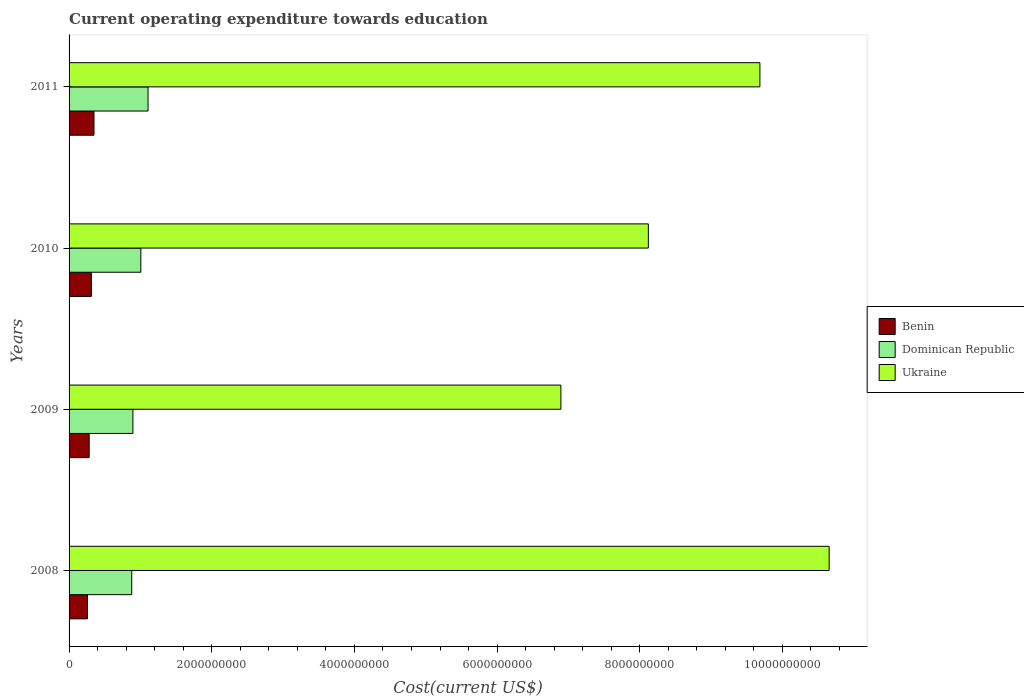How many different coloured bars are there?
Offer a terse response. 3. How many groups of bars are there?
Your response must be concise. 4. How many bars are there on the 3rd tick from the bottom?
Provide a succinct answer. 3. In how many cases, is the number of bars for a given year not equal to the number of legend labels?
Your answer should be very brief. 0. What is the expenditure towards education in Benin in 2009?
Ensure brevity in your answer.  2.82e+08. Across all years, what is the maximum expenditure towards education in Ukraine?
Provide a succinct answer. 1.07e+1. Across all years, what is the minimum expenditure towards education in Dominican Republic?
Your answer should be compact. 8.78e+08. In which year was the expenditure towards education in Dominican Republic maximum?
Provide a short and direct response. 2011. In which year was the expenditure towards education in Dominican Republic minimum?
Your response must be concise. 2008. What is the total expenditure towards education in Ukraine in the graph?
Keep it short and to the point. 3.54e+1. What is the difference between the expenditure towards education in Dominican Republic in 2009 and that in 2010?
Ensure brevity in your answer.  -1.11e+08. What is the difference between the expenditure towards education in Benin in 2010 and the expenditure towards education in Dominican Republic in 2011?
Offer a terse response. -7.95e+08. What is the average expenditure towards education in Ukraine per year?
Make the answer very short. 8.84e+09. In the year 2011, what is the difference between the expenditure towards education in Ukraine and expenditure towards education in Dominican Republic?
Offer a terse response. 8.58e+09. In how many years, is the expenditure towards education in Benin greater than 9200000000 US$?
Give a very brief answer. 0. What is the ratio of the expenditure towards education in Benin in 2008 to that in 2011?
Keep it short and to the point. 0.74. What is the difference between the highest and the second highest expenditure towards education in Ukraine?
Provide a succinct answer. 9.71e+08. What is the difference between the highest and the lowest expenditure towards education in Dominican Republic?
Your answer should be very brief. 2.29e+08. What does the 2nd bar from the top in 2011 represents?
Provide a short and direct response. Dominican Republic. What does the 1st bar from the bottom in 2010 represents?
Provide a succinct answer. Benin. How many bars are there?
Your answer should be compact. 12. Are all the bars in the graph horizontal?
Your response must be concise. Yes. What is the difference between two consecutive major ticks on the X-axis?
Offer a very short reply. 2.00e+09. Does the graph contain grids?
Provide a short and direct response. No. Where does the legend appear in the graph?
Your answer should be very brief. Center right. How are the legend labels stacked?
Your answer should be very brief. Vertical. What is the title of the graph?
Keep it short and to the point. Current operating expenditure towards education. Does "Fiji" appear as one of the legend labels in the graph?
Your response must be concise. No. What is the label or title of the X-axis?
Your answer should be compact. Cost(current US$). What is the label or title of the Y-axis?
Your answer should be very brief. Years. What is the Cost(current US$) in Benin in 2008?
Make the answer very short. 2.58e+08. What is the Cost(current US$) of Dominican Republic in 2008?
Offer a terse response. 8.78e+08. What is the Cost(current US$) of Ukraine in 2008?
Provide a short and direct response. 1.07e+1. What is the Cost(current US$) in Benin in 2009?
Ensure brevity in your answer.  2.82e+08. What is the Cost(current US$) of Dominican Republic in 2009?
Your response must be concise. 8.95e+08. What is the Cost(current US$) in Ukraine in 2009?
Ensure brevity in your answer.  6.89e+09. What is the Cost(current US$) in Benin in 2010?
Your response must be concise. 3.12e+08. What is the Cost(current US$) of Dominican Republic in 2010?
Ensure brevity in your answer.  1.01e+09. What is the Cost(current US$) in Ukraine in 2010?
Ensure brevity in your answer.  8.12e+09. What is the Cost(current US$) of Benin in 2011?
Your response must be concise. 3.49e+08. What is the Cost(current US$) in Dominican Republic in 2011?
Offer a terse response. 1.11e+09. What is the Cost(current US$) in Ukraine in 2011?
Your answer should be compact. 9.68e+09. Across all years, what is the maximum Cost(current US$) in Benin?
Provide a short and direct response. 3.49e+08. Across all years, what is the maximum Cost(current US$) in Dominican Republic?
Offer a very short reply. 1.11e+09. Across all years, what is the maximum Cost(current US$) of Ukraine?
Ensure brevity in your answer.  1.07e+1. Across all years, what is the minimum Cost(current US$) of Benin?
Offer a very short reply. 2.58e+08. Across all years, what is the minimum Cost(current US$) of Dominican Republic?
Keep it short and to the point. 8.78e+08. Across all years, what is the minimum Cost(current US$) in Ukraine?
Your response must be concise. 6.89e+09. What is the total Cost(current US$) in Benin in the graph?
Your answer should be compact. 1.20e+09. What is the total Cost(current US$) in Dominican Republic in the graph?
Provide a succinct answer. 3.89e+09. What is the total Cost(current US$) of Ukraine in the graph?
Provide a succinct answer. 3.54e+1. What is the difference between the Cost(current US$) in Benin in 2008 and that in 2009?
Ensure brevity in your answer.  -2.35e+07. What is the difference between the Cost(current US$) of Dominican Republic in 2008 and that in 2009?
Ensure brevity in your answer.  -1.65e+07. What is the difference between the Cost(current US$) of Ukraine in 2008 and that in 2009?
Make the answer very short. 3.76e+09. What is the difference between the Cost(current US$) in Benin in 2008 and that in 2010?
Your answer should be compact. -5.41e+07. What is the difference between the Cost(current US$) in Dominican Republic in 2008 and that in 2010?
Your answer should be very brief. -1.28e+08. What is the difference between the Cost(current US$) in Ukraine in 2008 and that in 2010?
Keep it short and to the point. 2.53e+09. What is the difference between the Cost(current US$) in Benin in 2008 and that in 2011?
Give a very brief answer. -9.09e+07. What is the difference between the Cost(current US$) in Dominican Republic in 2008 and that in 2011?
Keep it short and to the point. -2.29e+08. What is the difference between the Cost(current US$) of Ukraine in 2008 and that in 2011?
Ensure brevity in your answer.  9.71e+08. What is the difference between the Cost(current US$) of Benin in 2009 and that in 2010?
Your answer should be compact. -3.07e+07. What is the difference between the Cost(current US$) of Dominican Republic in 2009 and that in 2010?
Your response must be concise. -1.11e+08. What is the difference between the Cost(current US$) in Ukraine in 2009 and that in 2010?
Your answer should be compact. -1.23e+09. What is the difference between the Cost(current US$) in Benin in 2009 and that in 2011?
Ensure brevity in your answer.  -6.75e+07. What is the difference between the Cost(current US$) in Dominican Republic in 2009 and that in 2011?
Provide a short and direct response. -2.12e+08. What is the difference between the Cost(current US$) of Ukraine in 2009 and that in 2011?
Provide a succinct answer. -2.79e+09. What is the difference between the Cost(current US$) of Benin in 2010 and that in 2011?
Your response must be concise. -3.68e+07. What is the difference between the Cost(current US$) in Dominican Republic in 2010 and that in 2011?
Your answer should be very brief. -1.01e+08. What is the difference between the Cost(current US$) of Ukraine in 2010 and that in 2011?
Ensure brevity in your answer.  -1.56e+09. What is the difference between the Cost(current US$) of Benin in 2008 and the Cost(current US$) of Dominican Republic in 2009?
Your response must be concise. -6.37e+08. What is the difference between the Cost(current US$) of Benin in 2008 and the Cost(current US$) of Ukraine in 2009?
Provide a short and direct response. -6.64e+09. What is the difference between the Cost(current US$) of Dominican Republic in 2008 and the Cost(current US$) of Ukraine in 2009?
Ensure brevity in your answer.  -6.02e+09. What is the difference between the Cost(current US$) in Benin in 2008 and the Cost(current US$) in Dominican Republic in 2010?
Ensure brevity in your answer.  -7.48e+08. What is the difference between the Cost(current US$) of Benin in 2008 and the Cost(current US$) of Ukraine in 2010?
Ensure brevity in your answer.  -7.86e+09. What is the difference between the Cost(current US$) of Dominican Republic in 2008 and the Cost(current US$) of Ukraine in 2010?
Your answer should be compact. -7.24e+09. What is the difference between the Cost(current US$) in Benin in 2008 and the Cost(current US$) in Dominican Republic in 2011?
Provide a succinct answer. -8.49e+08. What is the difference between the Cost(current US$) in Benin in 2008 and the Cost(current US$) in Ukraine in 2011?
Offer a terse response. -9.43e+09. What is the difference between the Cost(current US$) of Dominican Republic in 2008 and the Cost(current US$) of Ukraine in 2011?
Keep it short and to the point. -8.81e+09. What is the difference between the Cost(current US$) of Benin in 2009 and the Cost(current US$) of Dominican Republic in 2010?
Keep it short and to the point. -7.24e+08. What is the difference between the Cost(current US$) of Benin in 2009 and the Cost(current US$) of Ukraine in 2010?
Your answer should be very brief. -7.84e+09. What is the difference between the Cost(current US$) in Dominican Republic in 2009 and the Cost(current US$) in Ukraine in 2010?
Your answer should be very brief. -7.23e+09. What is the difference between the Cost(current US$) of Benin in 2009 and the Cost(current US$) of Dominican Republic in 2011?
Your answer should be compact. -8.25e+08. What is the difference between the Cost(current US$) in Benin in 2009 and the Cost(current US$) in Ukraine in 2011?
Give a very brief answer. -9.40e+09. What is the difference between the Cost(current US$) in Dominican Republic in 2009 and the Cost(current US$) in Ukraine in 2011?
Make the answer very short. -8.79e+09. What is the difference between the Cost(current US$) of Benin in 2010 and the Cost(current US$) of Dominican Republic in 2011?
Make the answer very short. -7.95e+08. What is the difference between the Cost(current US$) in Benin in 2010 and the Cost(current US$) in Ukraine in 2011?
Keep it short and to the point. -9.37e+09. What is the difference between the Cost(current US$) of Dominican Republic in 2010 and the Cost(current US$) of Ukraine in 2011?
Give a very brief answer. -8.68e+09. What is the average Cost(current US$) of Benin per year?
Make the answer very short. 3.00e+08. What is the average Cost(current US$) of Dominican Republic per year?
Ensure brevity in your answer.  9.72e+08. What is the average Cost(current US$) of Ukraine per year?
Your answer should be compact. 8.84e+09. In the year 2008, what is the difference between the Cost(current US$) in Benin and Cost(current US$) in Dominican Republic?
Provide a succinct answer. -6.20e+08. In the year 2008, what is the difference between the Cost(current US$) in Benin and Cost(current US$) in Ukraine?
Your response must be concise. -1.04e+1. In the year 2008, what is the difference between the Cost(current US$) in Dominican Republic and Cost(current US$) in Ukraine?
Your answer should be compact. -9.78e+09. In the year 2009, what is the difference between the Cost(current US$) of Benin and Cost(current US$) of Dominican Republic?
Offer a terse response. -6.13e+08. In the year 2009, what is the difference between the Cost(current US$) in Benin and Cost(current US$) in Ukraine?
Your answer should be very brief. -6.61e+09. In the year 2009, what is the difference between the Cost(current US$) in Dominican Republic and Cost(current US$) in Ukraine?
Your response must be concise. -6.00e+09. In the year 2010, what is the difference between the Cost(current US$) of Benin and Cost(current US$) of Dominican Republic?
Your answer should be very brief. -6.94e+08. In the year 2010, what is the difference between the Cost(current US$) in Benin and Cost(current US$) in Ukraine?
Your response must be concise. -7.81e+09. In the year 2010, what is the difference between the Cost(current US$) in Dominican Republic and Cost(current US$) in Ukraine?
Make the answer very short. -7.11e+09. In the year 2011, what is the difference between the Cost(current US$) of Benin and Cost(current US$) of Dominican Republic?
Your response must be concise. -7.58e+08. In the year 2011, what is the difference between the Cost(current US$) of Benin and Cost(current US$) of Ukraine?
Your answer should be very brief. -9.33e+09. In the year 2011, what is the difference between the Cost(current US$) of Dominican Republic and Cost(current US$) of Ukraine?
Your answer should be compact. -8.58e+09. What is the ratio of the Cost(current US$) in Benin in 2008 to that in 2009?
Offer a terse response. 0.92. What is the ratio of the Cost(current US$) of Dominican Republic in 2008 to that in 2009?
Keep it short and to the point. 0.98. What is the ratio of the Cost(current US$) in Ukraine in 2008 to that in 2009?
Offer a very short reply. 1.55. What is the ratio of the Cost(current US$) in Benin in 2008 to that in 2010?
Your response must be concise. 0.83. What is the ratio of the Cost(current US$) of Dominican Republic in 2008 to that in 2010?
Your answer should be very brief. 0.87. What is the ratio of the Cost(current US$) of Ukraine in 2008 to that in 2010?
Make the answer very short. 1.31. What is the ratio of the Cost(current US$) of Benin in 2008 to that in 2011?
Your answer should be very brief. 0.74. What is the ratio of the Cost(current US$) in Dominican Republic in 2008 to that in 2011?
Keep it short and to the point. 0.79. What is the ratio of the Cost(current US$) of Ukraine in 2008 to that in 2011?
Your answer should be compact. 1.1. What is the ratio of the Cost(current US$) in Benin in 2009 to that in 2010?
Keep it short and to the point. 0.9. What is the ratio of the Cost(current US$) in Dominican Republic in 2009 to that in 2010?
Your answer should be compact. 0.89. What is the ratio of the Cost(current US$) of Ukraine in 2009 to that in 2010?
Give a very brief answer. 0.85. What is the ratio of the Cost(current US$) in Benin in 2009 to that in 2011?
Your response must be concise. 0.81. What is the ratio of the Cost(current US$) of Dominican Republic in 2009 to that in 2011?
Your response must be concise. 0.81. What is the ratio of the Cost(current US$) of Ukraine in 2009 to that in 2011?
Ensure brevity in your answer.  0.71. What is the ratio of the Cost(current US$) in Benin in 2010 to that in 2011?
Your answer should be very brief. 0.89. What is the ratio of the Cost(current US$) of Dominican Republic in 2010 to that in 2011?
Your response must be concise. 0.91. What is the ratio of the Cost(current US$) in Ukraine in 2010 to that in 2011?
Provide a succinct answer. 0.84. What is the difference between the highest and the second highest Cost(current US$) in Benin?
Offer a terse response. 3.68e+07. What is the difference between the highest and the second highest Cost(current US$) in Dominican Republic?
Provide a short and direct response. 1.01e+08. What is the difference between the highest and the second highest Cost(current US$) in Ukraine?
Your answer should be very brief. 9.71e+08. What is the difference between the highest and the lowest Cost(current US$) of Benin?
Offer a very short reply. 9.09e+07. What is the difference between the highest and the lowest Cost(current US$) in Dominican Republic?
Ensure brevity in your answer.  2.29e+08. What is the difference between the highest and the lowest Cost(current US$) of Ukraine?
Make the answer very short. 3.76e+09. 